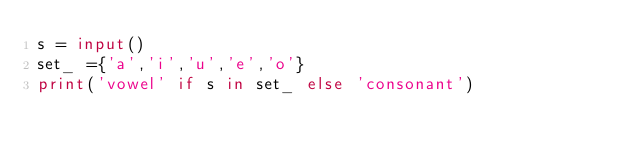<code> <loc_0><loc_0><loc_500><loc_500><_Python_>s = input()
set_ ={'a','i','u','e','o'}
print('vowel' if s in set_ else 'consonant')</code> 